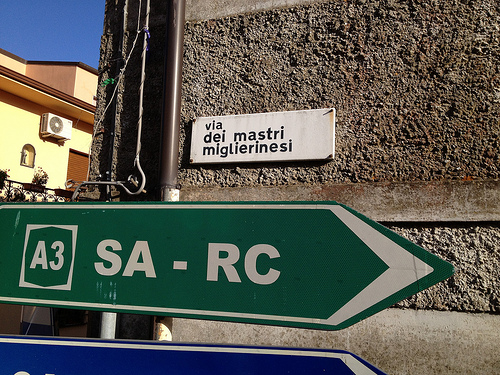How many air conditioning units are attached to the yellow building? Upon reviewing the image, it's not possible to confirm the presence of any air conditioning units attached to the buildings visible. A more thorough observation might be needed to provide an accurate count. 